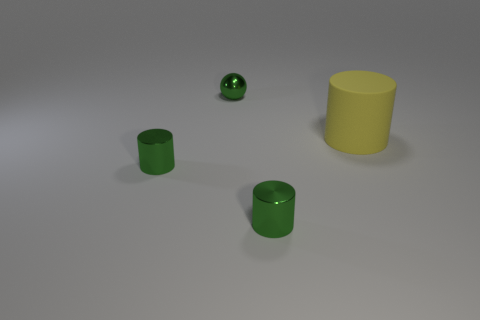Add 2 tiny metal blocks. How many objects exist? 6 Subtract all cylinders. How many objects are left? 1 Add 1 yellow rubber cylinders. How many yellow rubber cylinders exist? 2 Subtract 0 yellow blocks. How many objects are left? 4 Subtract all green cylinders. Subtract all balls. How many objects are left? 1 Add 3 tiny green spheres. How many tiny green spheres are left? 4 